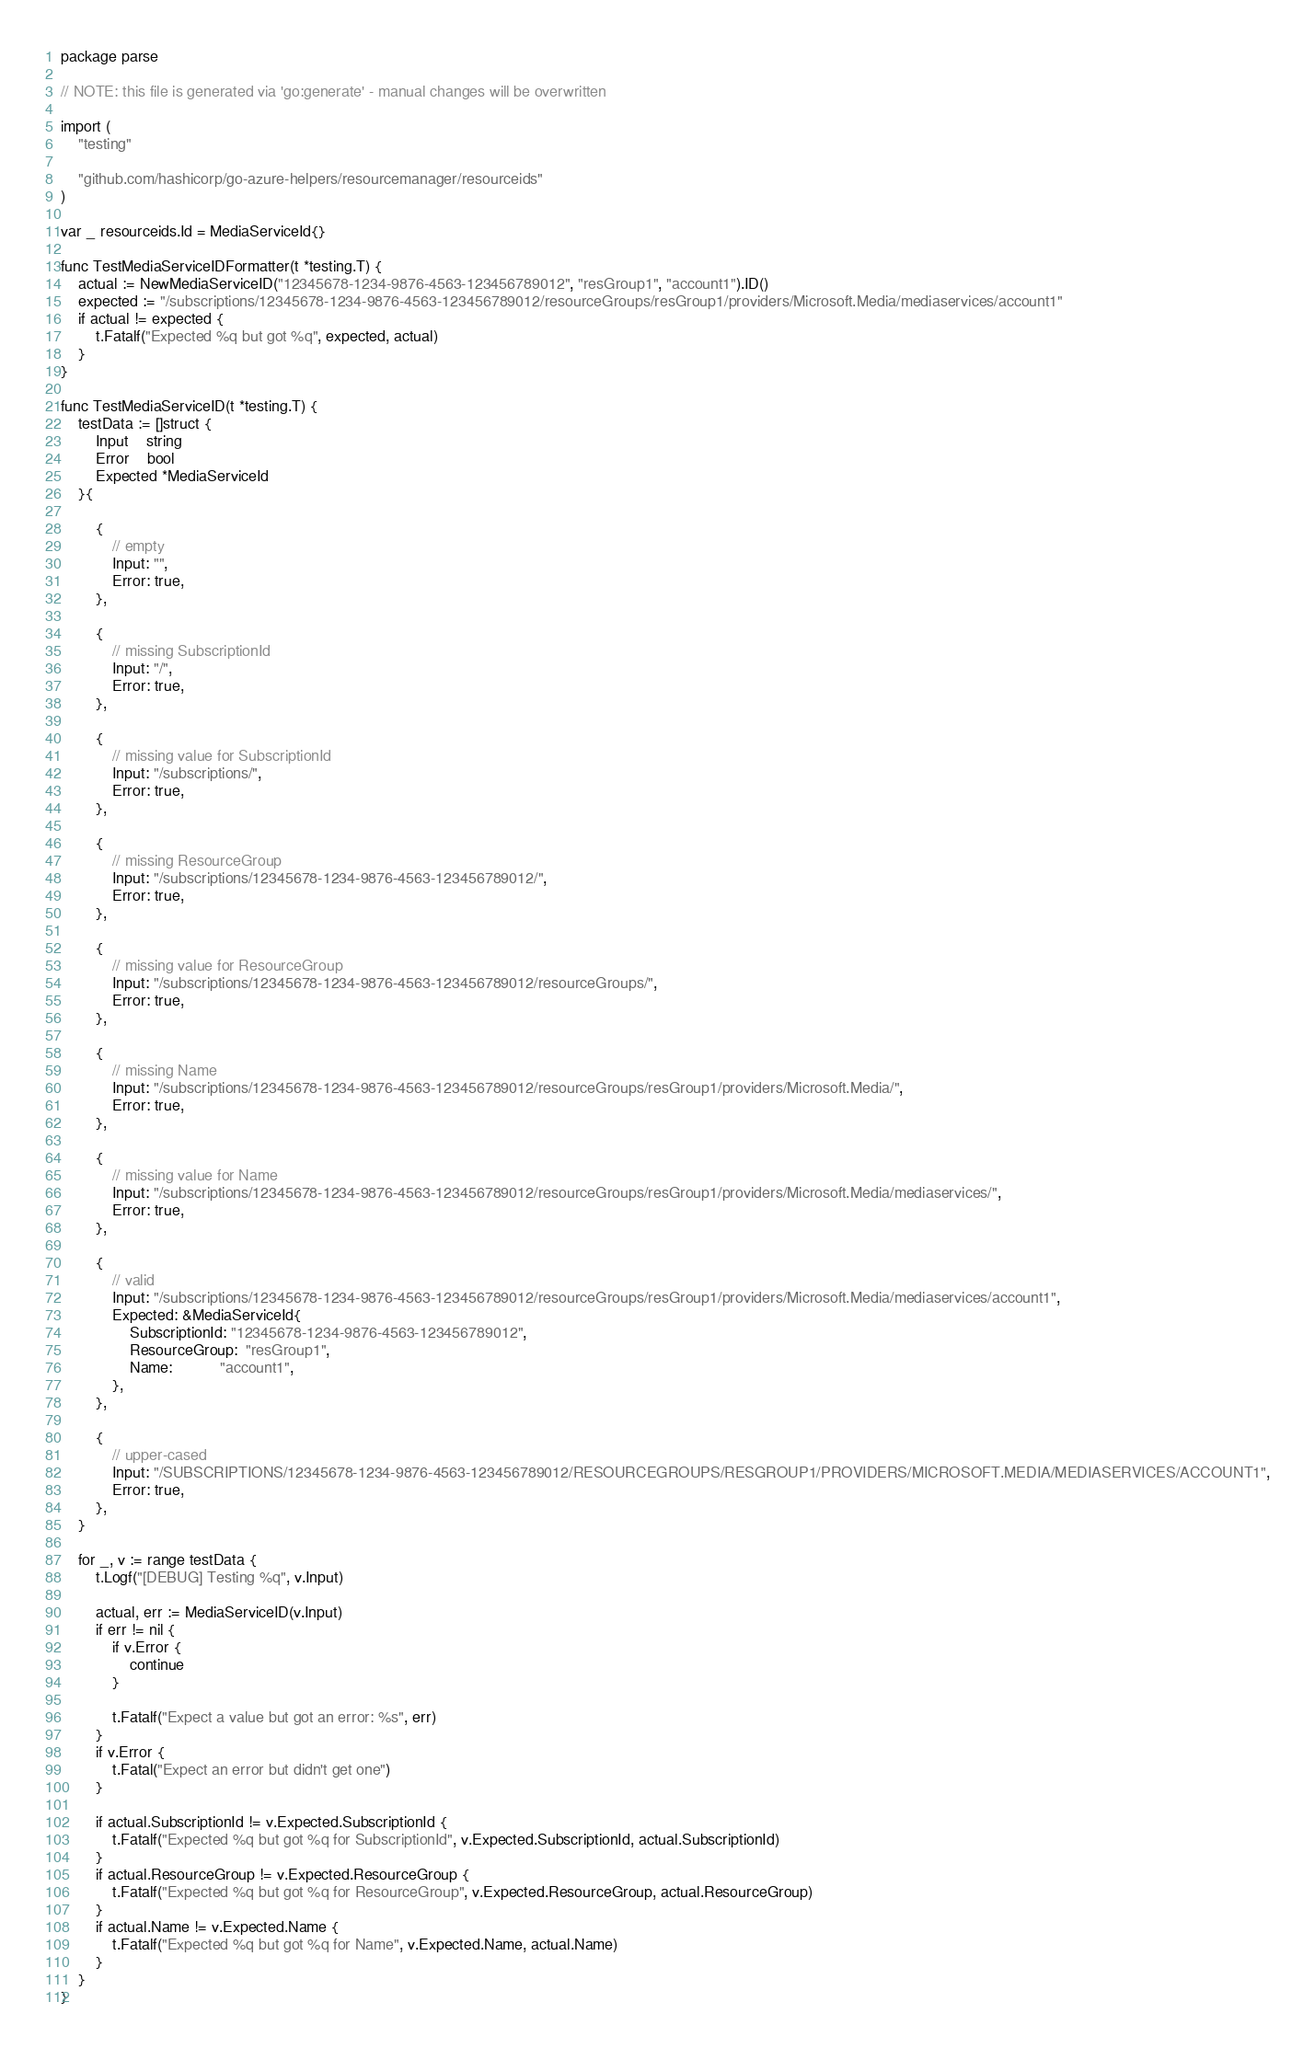<code> <loc_0><loc_0><loc_500><loc_500><_Go_>package parse

// NOTE: this file is generated via 'go:generate' - manual changes will be overwritten

import (
	"testing"

	"github.com/hashicorp/go-azure-helpers/resourcemanager/resourceids"
)

var _ resourceids.Id = MediaServiceId{}

func TestMediaServiceIDFormatter(t *testing.T) {
	actual := NewMediaServiceID("12345678-1234-9876-4563-123456789012", "resGroup1", "account1").ID()
	expected := "/subscriptions/12345678-1234-9876-4563-123456789012/resourceGroups/resGroup1/providers/Microsoft.Media/mediaservices/account1"
	if actual != expected {
		t.Fatalf("Expected %q but got %q", expected, actual)
	}
}

func TestMediaServiceID(t *testing.T) {
	testData := []struct {
		Input    string
		Error    bool
		Expected *MediaServiceId
	}{

		{
			// empty
			Input: "",
			Error: true,
		},

		{
			// missing SubscriptionId
			Input: "/",
			Error: true,
		},

		{
			// missing value for SubscriptionId
			Input: "/subscriptions/",
			Error: true,
		},

		{
			// missing ResourceGroup
			Input: "/subscriptions/12345678-1234-9876-4563-123456789012/",
			Error: true,
		},

		{
			// missing value for ResourceGroup
			Input: "/subscriptions/12345678-1234-9876-4563-123456789012/resourceGroups/",
			Error: true,
		},

		{
			// missing Name
			Input: "/subscriptions/12345678-1234-9876-4563-123456789012/resourceGroups/resGroup1/providers/Microsoft.Media/",
			Error: true,
		},

		{
			// missing value for Name
			Input: "/subscriptions/12345678-1234-9876-4563-123456789012/resourceGroups/resGroup1/providers/Microsoft.Media/mediaservices/",
			Error: true,
		},

		{
			// valid
			Input: "/subscriptions/12345678-1234-9876-4563-123456789012/resourceGroups/resGroup1/providers/Microsoft.Media/mediaservices/account1",
			Expected: &MediaServiceId{
				SubscriptionId: "12345678-1234-9876-4563-123456789012",
				ResourceGroup:  "resGroup1",
				Name:           "account1",
			},
		},

		{
			// upper-cased
			Input: "/SUBSCRIPTIONS/12345678-1234-9876-4563-123456789012/RESOURCEGROUPS/RESGROUP1/PROVIDERS/MICROSOFT.MEDIA/MEDIASERVICES/ACCOUNT1",
			Error: true,
		},
	}

	for _, v := range testData {
		t.Logf("[DEBUG] Testing %q", v.Input)

		actual, err := MediaServiceID(v.Input)
		if err != nil {
			if v.Error {
				continue
			}

			t.Fatalf("Expect a value but got an error: %s", err)
		}
		if v.Error {
			t.Fatal("Expect an error but didn't get one")
		}

		if actual.SubscriptionId != v.Expected.SubscriptionId {
			t.Fatalf("Expected %q but got %q for SubscriptionId", v.Expected.SubscriptionId, actual.SubscriptionId)
		}
		if actual.ResourceGroup != v.Expected.ResourceGroup {
			t.Fatalf("Expected %q but got %q for ResourceGroup", v.Expected.ResourceGroup, actual.ResourceGroup)
		}
		if actual.Name != v.Expected.Name {
			t.Fatalf("Expected %q but got %q for Name", v.Expected.Name, actual.Name)
		}
	}
}
</code> 